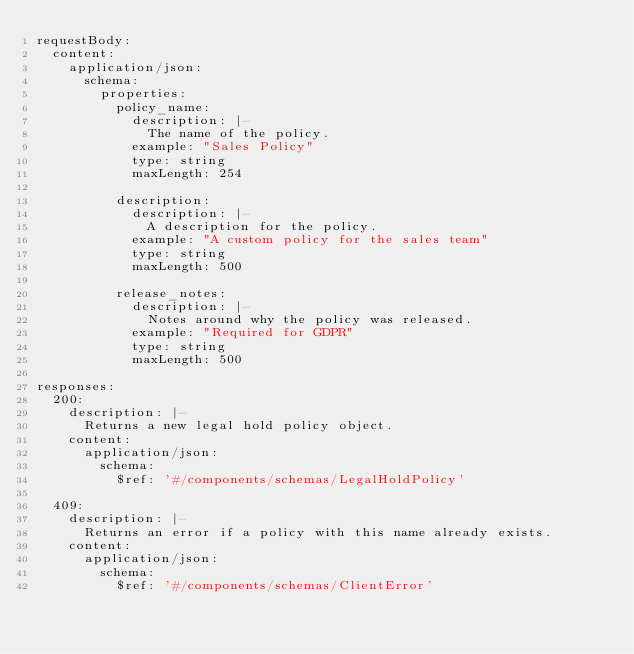<code> <loc_0><loc_0><loc_500><loc_500><_YAML_>requestBody:
  content:
    application/json:
      schema:
        properties:
          policy_name:
            description: |-
              The name of the policy.
            example: "Sales Policy"
            type: string
            maxLength: 254

          description:
            description: |-
              A description for the policy.
            example: "A custom policy for the sales team"
            type: string
            maxLength: 500

          release_notes:
            description: |-
              Notes around why the policy was released.
            example: "Required for GDPR"
            type: string
            maxLength: 500

responses:
  200:
    description: |-
      Returns a new legal hold policy object.
    content:
      application/json:
        schema:
          $ref: '#/components/schemas/LegalHoldPolicy'

  409:
    description: |-
      Returns an error if a policy with this name already exists.
    content:
      application/json:
        schema:
          $ref: '#/components/schemas/ClientError'
</code> 